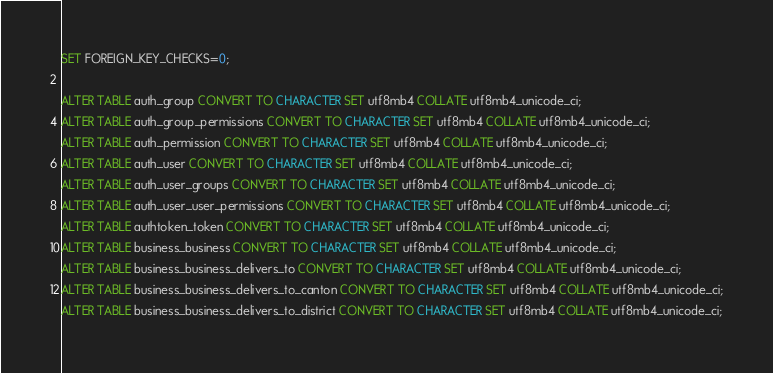<code> <loc_0><loc_0><loc_500><loc_500><_SQL_>
SET FOREIGN_KEY_CHECKS=0;

ALTER TABLE auth_group CONVERT TO CHARACTER SET utf8mb4 COLLATE utf8mb4_unicode_ci;
ALTER TABLE auth_group_permissions CONVERT TO CHARACTER SET utf8mb4 COLLATE utf8mb4_unicode_ci;
ALTER TABLE auth_permission CONVERT TO CHARACTER SET utf8mb4 COLLATE utf8mb4_unicode_ci;
ALTER TABLE auth_user CONVERT TO CHARACTER SET utf8mb4 COLLATE utf8mb4_unicode_ci;
ALTER TABLE auth_user_groups CONVERT TO CHARACTER SET utf8mb4 COLLATE utf8mb4_unicode_ci;
ALTER TABLE auth_user_user_permissions CONVERT TO CHARACTER SET utf8mb4 COLLATE utf8mb4_unicode_ci;
ALTER TABLE authtoken_token CONVERT TO CHARACTER SET utf8mb4 COLLATE utf8mb4_unicode_ci;
ALTER TABLE business_business CONVERT TO CHARACTER SET utf8mb4 COLLATE utf8mb4_unicode_ci;
ALTER TABLE business_business_delivers_to CONVERT TO CHARACTER SET utf8mb4 COLLATE utf8mb4_unicode_ci;
ALTER TABLE business_business_delivers_to_canton CONVERT TO CHARACTER SET utf8mb4 COLLATE utf8mb4_unicode_ci;
ALTER TABLE business_business_delivers_to_district CONVERT TO CHARACTER SET utf8mb4 COLLATE utf8mb4_unicode_ci;</code> 